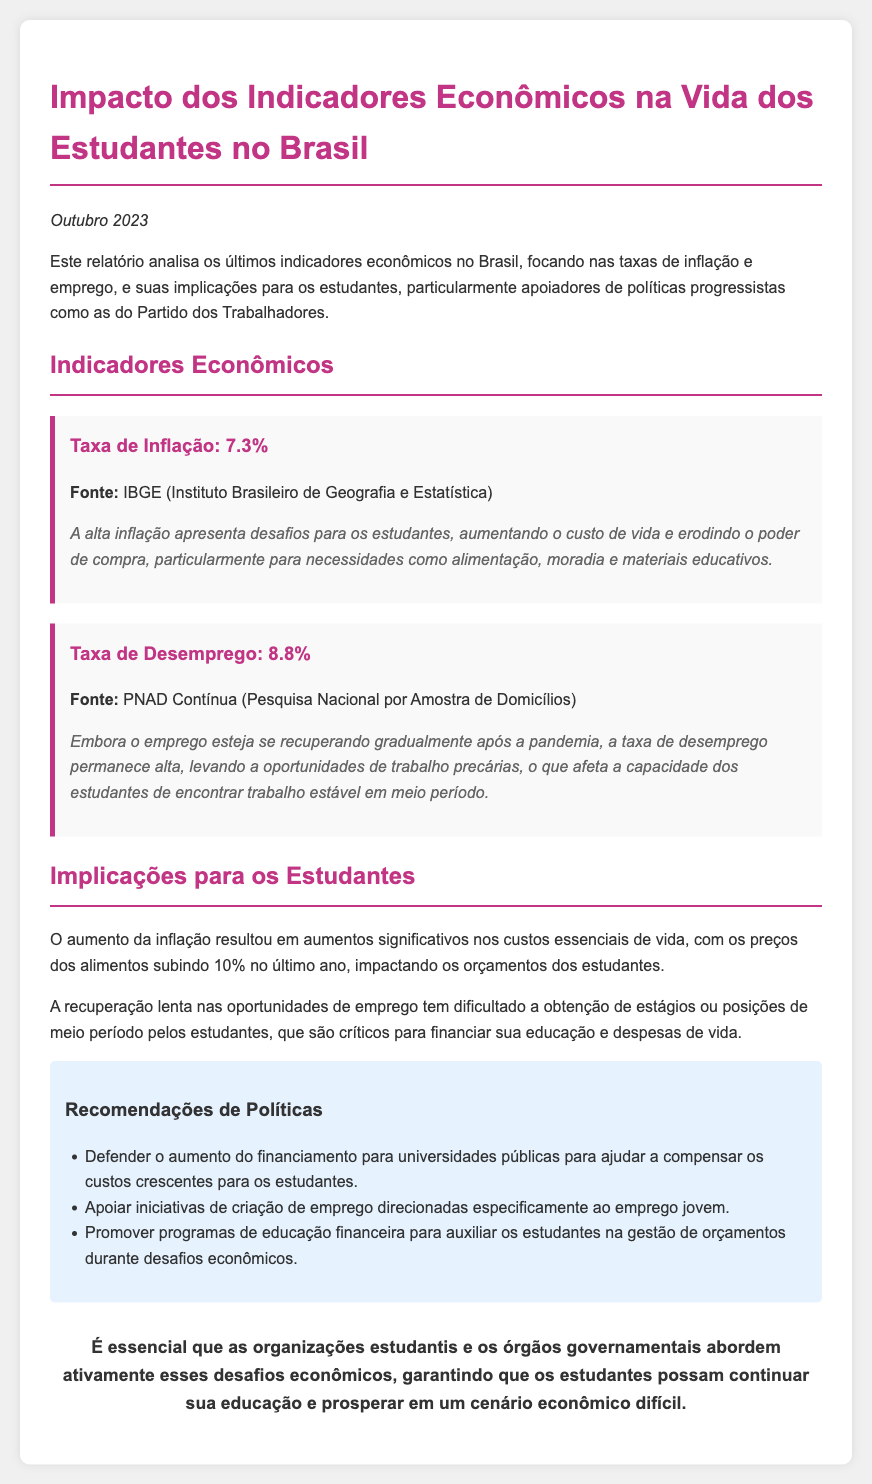what is the inflation rate? The inflation rate is provided in the document under economic indicators, listed as 7.3%.
Answer: 7.3% what is the unemployment rate? The unemployment rate is detailed in the document as 8.8%.
Answer: 8.8% what percentage did food prices rise in the last year? The document states that food prices increased by 10% last year.
Answer: 10% which institute provided the inflation data? The document specifies that the inflation data came from IBGE (Instituto Brasileiro de Geografia e Estatística).
Answer: IBGE what is one recommended policy to help students? The document suggests increasing funding for public universities as a policy recommendation to assist students.
Answer: Aumento do financiamento para universidades públicas how does high inflation impact students? According to the document, high inflation increases the cost of living and erodes purchasing power for essential needs.
Answer: Aumenta o custo de vida what challenges do students face due to unemployment? The document indicates that students face challenges in finding stable part-time work due to high unemployment.
Answer: Falta de trabalho estável which month and year was the report published? The report's publication date is mentioned as October 2023.
Answer: Outubro 2023 who is responsible for addressing the economic challenges mentioned? The conclusion of the document states that student organizations and government bodies should actively address these challenges.
Answer: Organizações estudantis e órgãos governamentais 